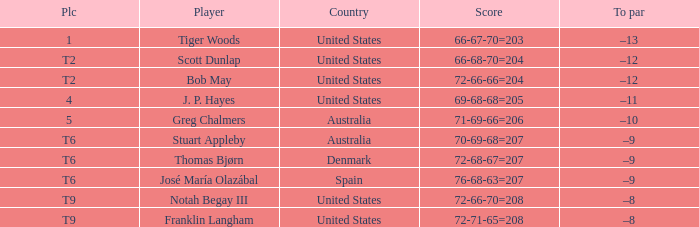What is the place of the player with a 72-71-65=208 score? T9. Can you give me this table as a dict? {'header': ['Plc', 'Player', 'Country', 'Score', 'To par'], 'rows': [['1', 'Tiger Woods', 'United States', '66-67-70=203', '–13'], ['T2', 'Scott Dunlap', 'United States', '66-68-70=204', '–12'], ['T2', 'Bob May', 'United States', '72-66-66=204', '–12'], ['4', 'J. P. Hayes', 'United States', '69-68-68=205', '–11'], ['5', 'Greg Chalmers', 'Australia', '71-69-66=206', '–10'], ['T6', 'Stuart Appleby', 'Australia', '70-69-68=207', '–9'], ['T6', 'Thomas Bjørn', 'Denmark', '72-68-67=207', '–9'], ['T6', 'José María Olazábal', 'Spain', '76-68-63=207', '–9'], ['T9', 'Notah Begay III', 'United States', '72-66-70=208', '–8'], ['T9', 'Franklin Langham', 'United States', '72-71-65=208', '–8']]} 